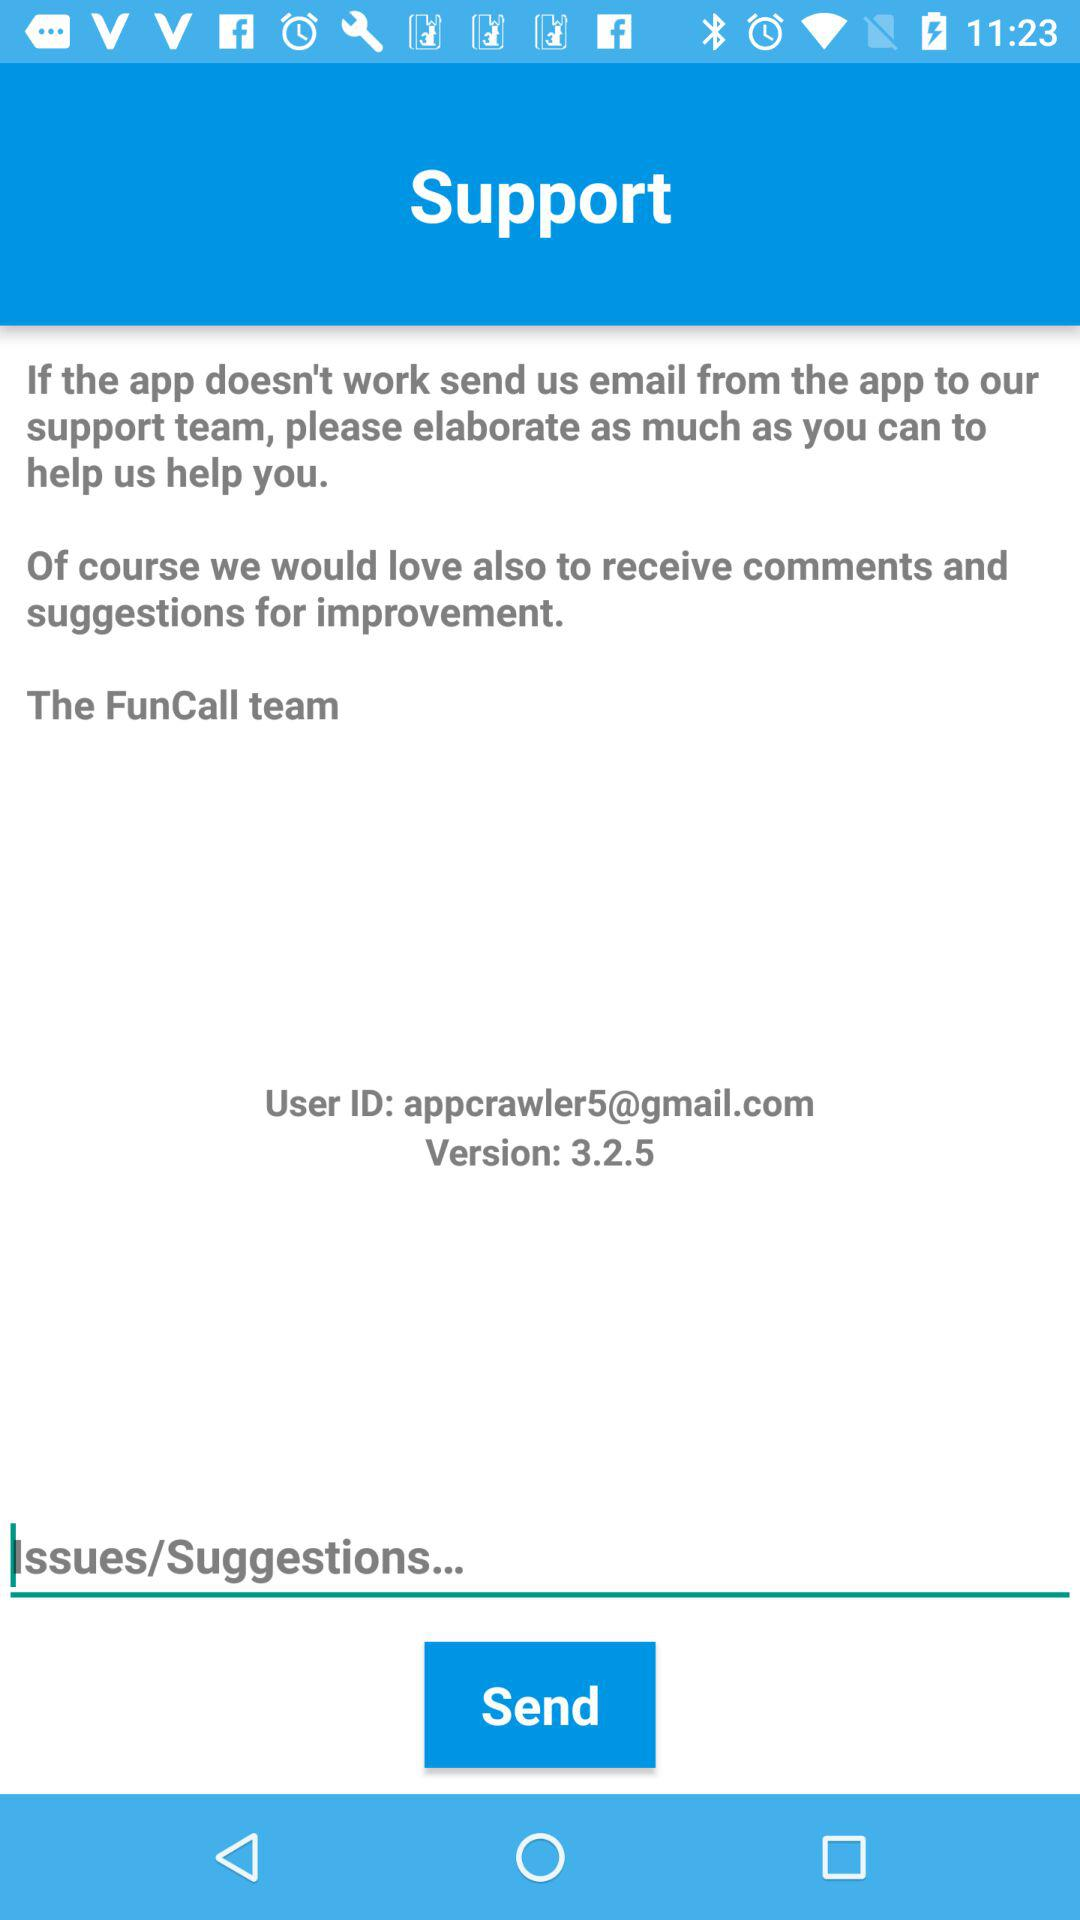What are the user's issues and suggestions?
When the provided information is insufficient, respond with <no answer>. <no answer> 